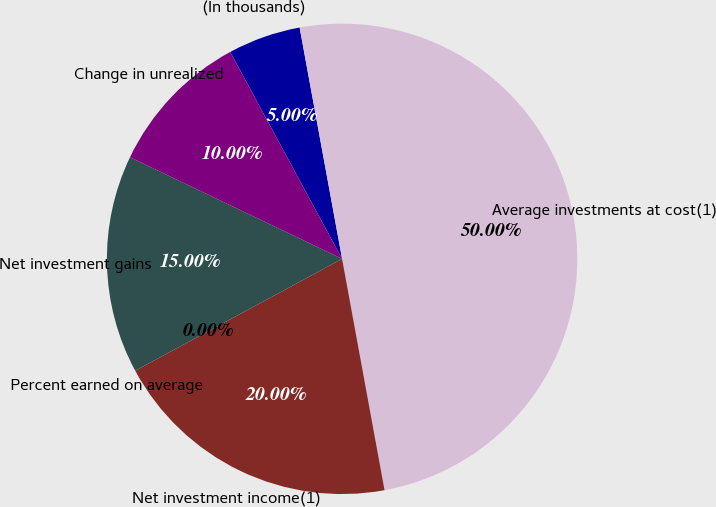Convert chart to OTSL. <chart><loc_0><loc_0><loc_500><loc_500><pie_chart><fcel>(In thousands)<fcel>Average investments at cost(1)<fcel>Net investment income(1)<fcel>Percent earned on average<fcel>Net investment gains<fcel>Change in unrealized<nl><fcel>5.0%<fcel>50.0%<fcel>20.0%<fcel>0.0%<fcel>15.0%<fcel>10.0%<nl></chart> 